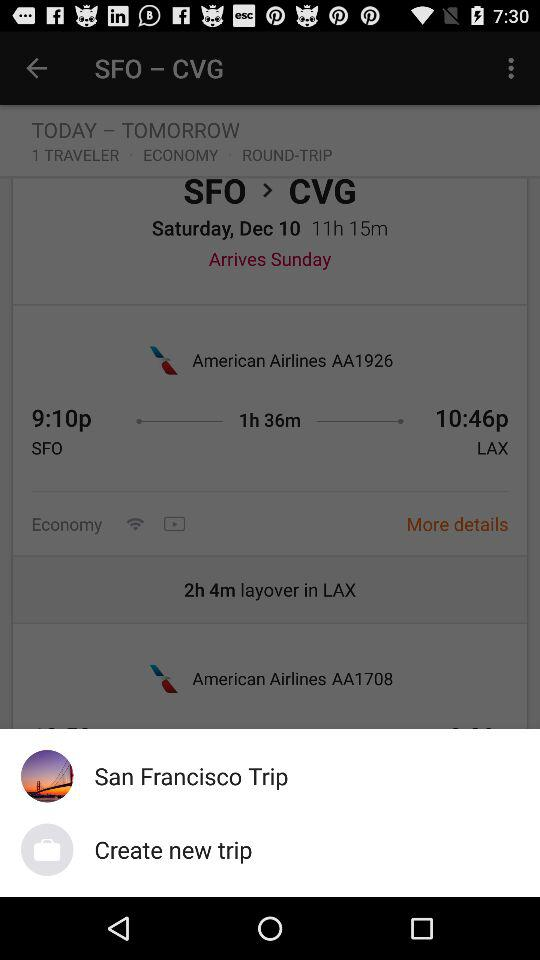What is the journey class? The journey class is "ECONOMY". 